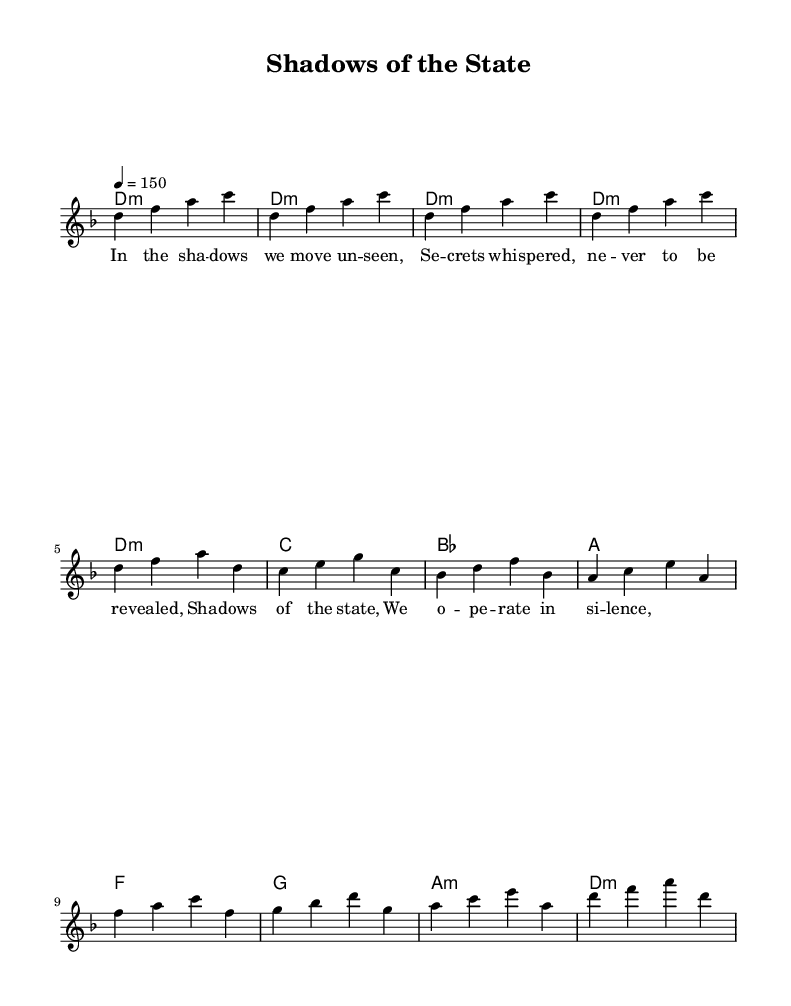What is the key signature of this music? The key signature is D minor, which has one flat (B flat) indicated by the corresponding symbol at the beginning of the staff.
Answer: D minor What is the time signature of this music? The time signature is 4/4, as indicated at the beginning of the score, meaning there are four beats in each measure.
Answer: 4/4 What is the tempo marking for this piece? The tempo marking is 150, indicating the speed of the piece, and is noted as "4 = 150" above the staff.
Answer: 150 How many measures are in the chorus section? The chorus section consists of four measures, as indicated in the score where the lyrics are assigned to the corresponding melody notes.
Answer: 4 What are the first three chords in the intro? The first three chords in the intro are all D minor, which is written as "d1:m" in the chord notation for three consecutive measures at the start.
Answer: D minor What is the lyrical theme of the first verse? The lyrical theme of the first verse discusses secrecy and being unseen, which is conveyed through the words "In the shadows we move unseen".
Answer: Secrecy How does the melody of the chorus differ from the verse? The melody of the chorus has a different set of notes than the verse, providing a contrast, and typically is more powerful and pronounced in metal compositions, which enhances the emotional impact.
Answer: Different notes 